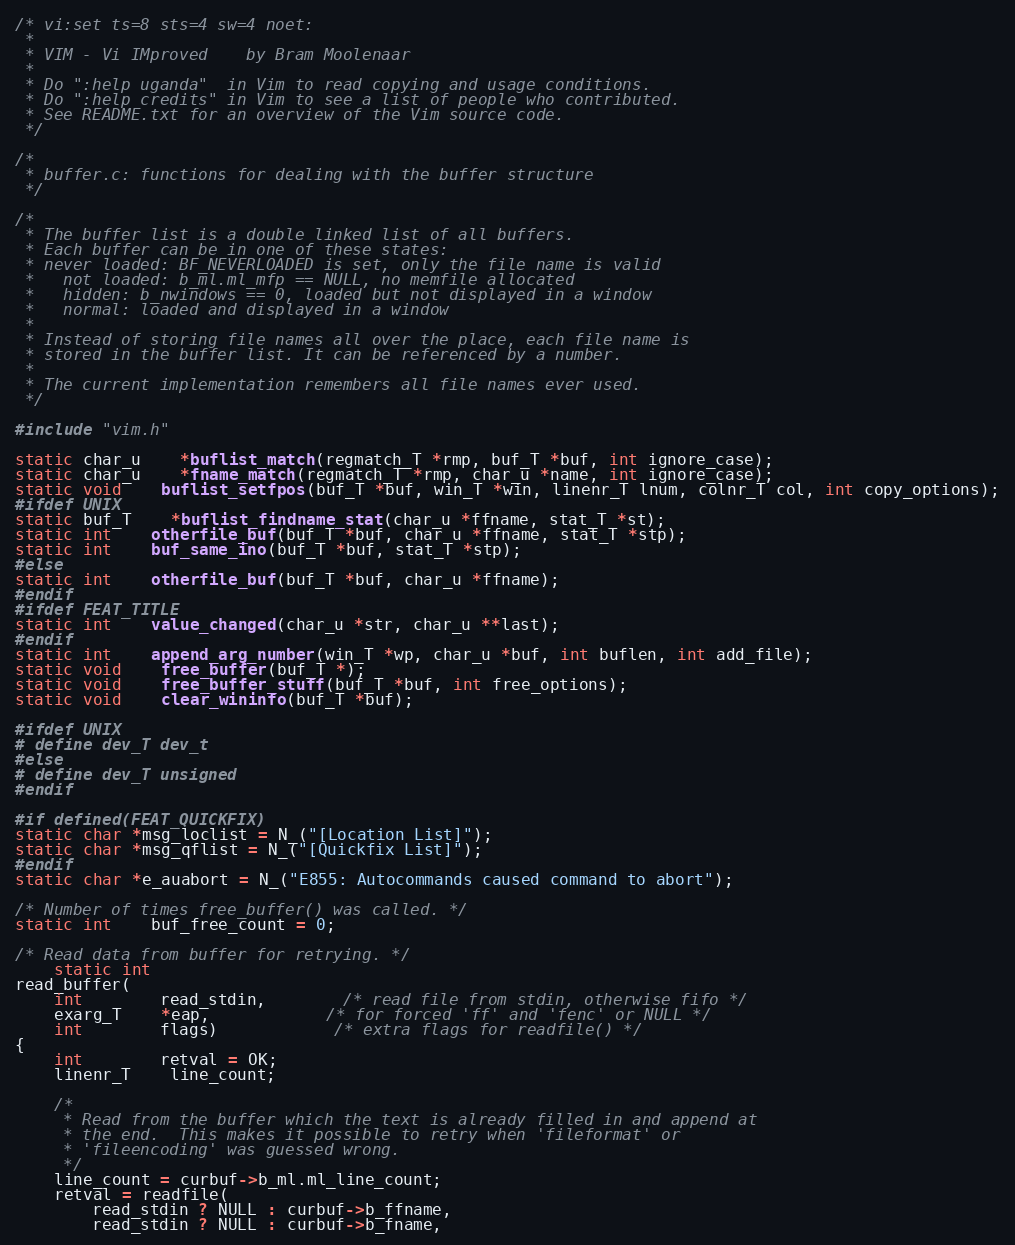<code> <loc_0><loc_0><loc_500><loc_500><_C_>/* vi:set ts=8 sts=4 sw=4 noet:
 *
 * VIM - Vi IMproved	by Bram Moolenaar
 *
 * Do ":help uganda"  in Vim to read copying and usage conditions.
 * Do ":help credits" in Vim to see a list of people who contributed.
 * See README.txt for an overview of the Vim source code.
 */

/*
 * buffer.c: functions for dealing with the buffer structure
 */

/*
 * The buffer list is a double linked list of all buffers.
 * Each buffer can be in one of these states:
 * never loaded: BF_NEVERLOADED is set, only the file name is valid
 *   not loaded: b_ml.ml_mfp == NULL, no memfile allocated
 *	 hidden: b_nwindows == 0, loaded but not displayed in a window
 *	 normal: loaded and displayed in a window
 *
 * Instead of storing file names all over the place, each file name is
 * stored in the buffer list. It can be referenced by a number.
 *
 * The current implementation remembers all file names ever used.
 */

#include "vim.h"

static char_u	*buflist_match(regmatch_T *rmp, buf_T *buf, int ignore_case);
static char_u	*fname_match(regmatch_T *rmp, char_u *name, int ignore_case);
static void	buflist_setfpos(buf_T *buf, win_T *win, linenr_T lnum, colnr_T col, int copy_options);
#ifdef UNIX
static buf_T	*buflist_findname_stat(char_u *ffname, stat_T *st);
static int	otherfile_buf(buf_T *buf, char_u *ffname, stat_T *stp);
static int	buf_same_ino(buf_T *buf, stat_T *stp);
#else
static int	otherfile_buf(buf_T *buf, char_u *ffname);
#endif
#ifdef FEAT_TITLE
static int	value_changed(char_u *str, char_u **last);
#endif
static int	append_arg_number(win_T *wp, char_u *buf, int buflen, int add_file);
static void	free_buffer(buf_T *);
static void	free_buffer_stuff(buf_T *buf, int free_options);
static void	clear_wininfo(buf_T *buf);

#ifdef UNIX
# define dev_T dev_t
#else
# define dev_T unsigned
#endif

#if defined(FEAT_QUICKFIX)
static char *msg_loclist = N_("[Location List]");
static char *msg_qflist = N_("[Quickfix List]");
#endif
static char *e_auabort = N_("E855: Autocommands caused command to abort");

/* Number of times free_buffer() was called. */
static int	buf_free_count = 0;

/* Read data from buffer for retrying. */
    static int
read_buffer(
    int		read_stdin,	    /* read file from stdin, otherwise fifo */
    exarg_T	*eap,		    /* for forced 'ff' and 'fenc' or NULL */
    int		flags)		    /* extra flags for readfile() */
{
    int		retval = OK;
    linenr_T	line_count;

    /*
     * Read from the buffer which the text is already filled in and append at
     * the end.  This makes it possible to retry when 'fileformat' or
     * 'fileencoding' was guessed wrong.
     */
    line_count = curbuf->b_ml.ml_line_count;
    retval = readfile(
	    read_stdin ? NULL : curbuf->b_ffname,
	    read_stdin ? NULL : curbuf->b_fname,</code> 